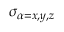<formula> <loc_0><loc_0><loc_500><loc_500>\sigma _ { \alpha = x , y , z }</formula> 